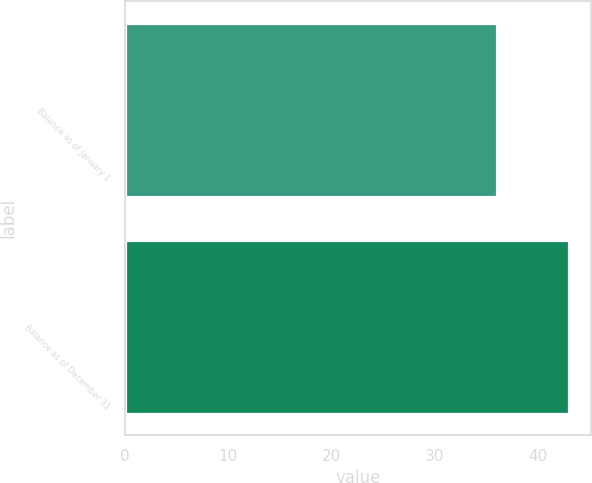Convert chart. <chart><loc_0><loc_0><loc_500><loc_500><bar_chart><fcel>Balance as of January 1<fcel>Balance as of December 31<nl><fcel>36<fcel>43<nl></chart> 